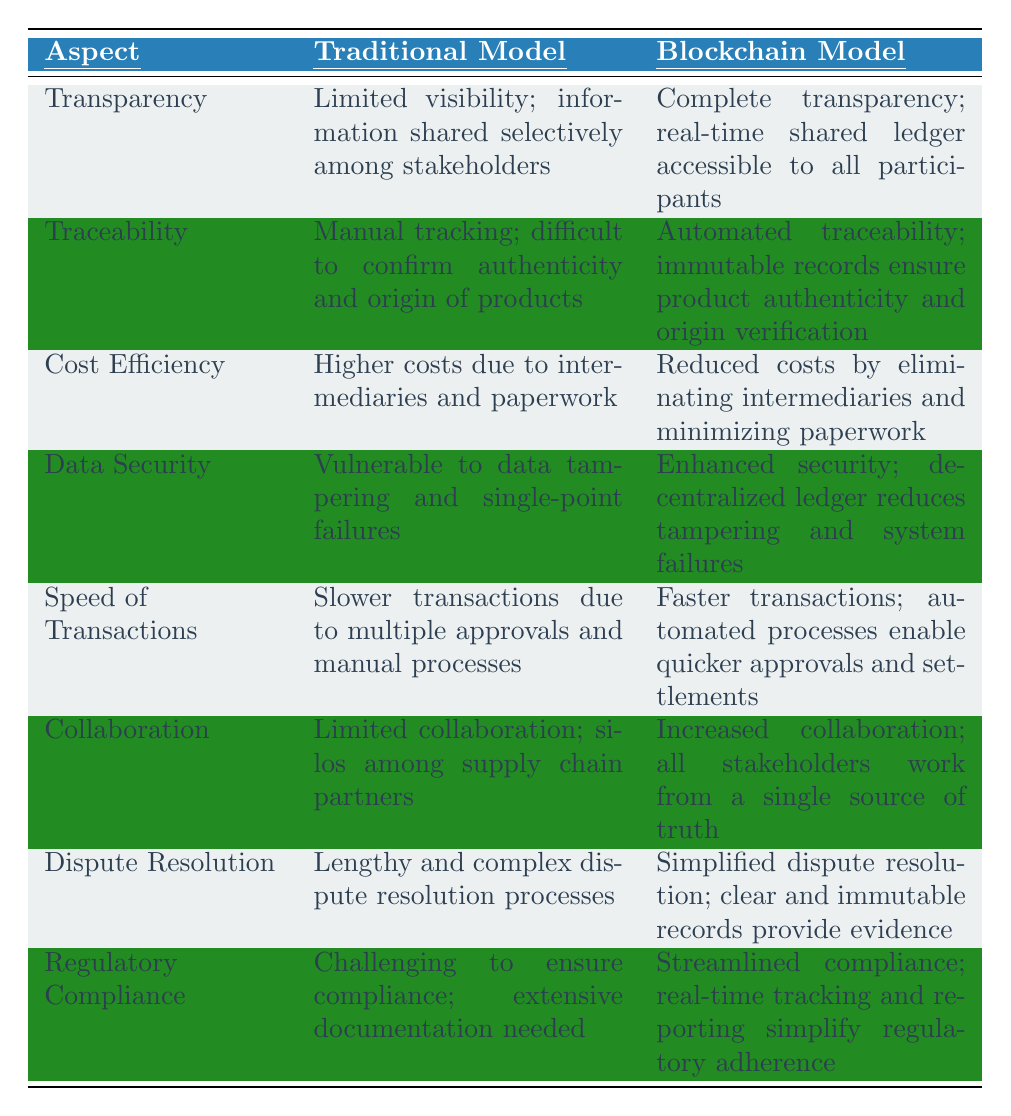What is the primary benefit of the Blockchain Model regarding transparency? The Blockchain Model offers complete transparency with a real-time shared ledger accessible to all participants, whereas the Traditional Model has limited visibility and shares information selectively.
Answer: Complete transparency How does traceability differ between the Traditional and Blockchain models? The Traditional Model relies on manual tracking, which makes confirming authenticity and product origin difficult, while the Blockchain Model provides automated traceability with immutable records.
Answer: Automated traceability Which model exhibits greater cost efficiency and why? The Blockchain Model is more cost-efficient because it reduces costs by eliminating intermediaries and minimizing paperwork, unlike the Traditional Model that incurs higher costs due to intermediaries.
Answer: Blockchain Model Is data security better in the Traditional Model than in the Blockchain Model? No, data security is enhanced in the Blockchain Model due to its decentralized ledger reducing tampering and system failures, making it more secure than the Traditional Model.
Answer: No How do the transaction speeds compare between the two models? The Blockchain Model enables faster transactions through automated processes that allow quicker approvals and settlements, while the Traditional Model slows down due to multiple approvals and manual processes.
Answer: Blockchain Model is faster In terms of collaboration, which model is superior and why? The Blockchain Model provides increased collaboration by allowing all stakeholders to work from a single source of truth, whereas the Traditional Model suffers from limited collaboration and silos among partners.
Answer: Blockchain Model What is the difference in dispute resolution processes between the two models? The Blockchain Model simplifies dispute resolution due to clear and immutable records that provide evidence, while the Traditional Model involves lengthy and complex processes.
Answer: Simplified in Blockchain Model Which model facilitates easier regulatory compliance? The Blockchain Model streamlines compliance by simplifying regulatory adherence through real-time tracking and reporting, compared to the Traditional Model which presents challenges due to extensive documentation needs.
Answer: Blockchain Model 